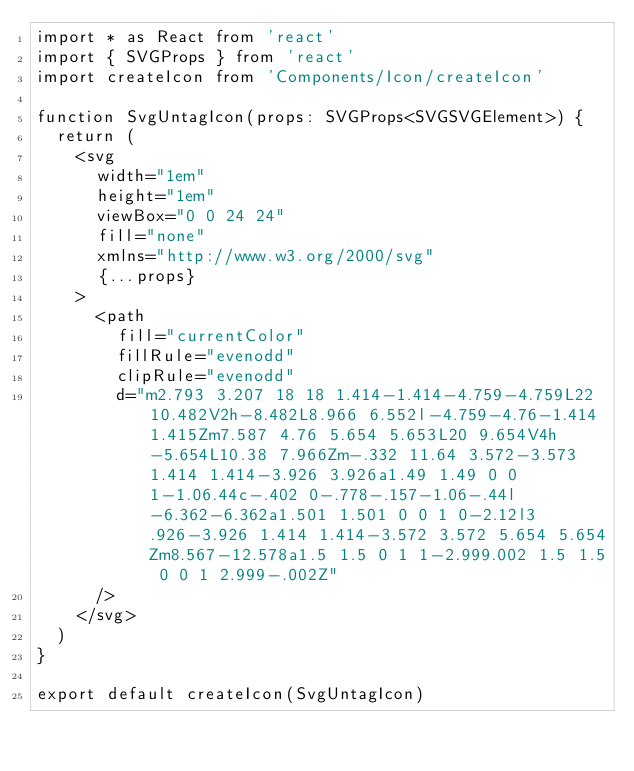Convert code to text. <code><loc_0><loc_0><loc_500><loc_500><_TypeScript_>import * as React from 'react'
import { SVGProps } from 'react'
import createIcon from 'Components/Icon/createIcon'

function SvgUntagIcon(props: SVGProps<SVGSVGElement>) {
  return (
    <svg
      width="1em"
      height="1em"
      viewBox="0 0 24 24"
      fill="none"
      xmlns="http://www.w3.org/2000/svg"
      {...props}
    >
      <path
        fill="currentColor"
        fillRule="evenodd"
        clipRule="evenodd"
        d="m2.793 3.207 18 18 1.414-1.414-4.759-4.759L22 10.482V2h-8.482L8.966 6.552l-4.759-4.76-1.414 1.415Zm7.587 4.76 5.654 5.653L20 9.654V4h-5.654L10.38 7.966Zm-.332 11.64 3.572-3.573 1.414 1.414-3.926 3.926a1.49 1.49 0 0 1-1.06.44c-.402 0-.778-.157-1.06-.44l-6.362-6.362a1.501 1.501 0 0 1 0-2.12l3.926-3.926 1.414 1.414-3.572 3.572 5.654 5.654Zm8.567-12.578a1.5 1.5 0 1 1-2.999.002 1.5 1.5 0 0 1 2.999-.002Z"
      />
    </svg>
  )
}

export default createIcon(SvgUntagIcon)
</code> 